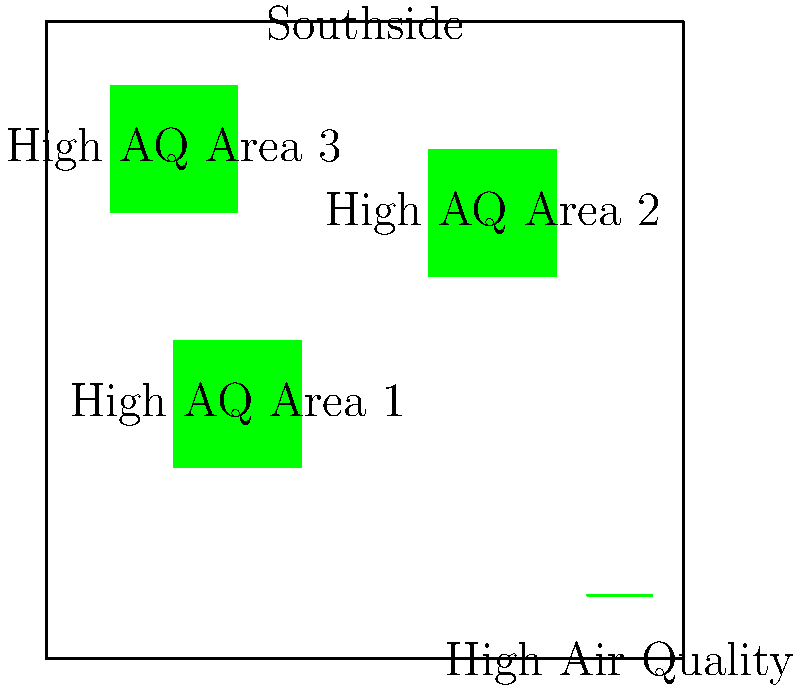According to the map of Chattanooga's Southside, how many distinct areas are highlighted as having the highest air quality readings? To answer this question, we need to carefully examine the provided map of Chattanooga's Southside. The map uses green shading to indicate areas with the highest air quality readings. Let's analyze the map step-by-step:

1. Observe the overall layout of the map, which shows the Southside area of Chattanooga.

2. Look for green-shaded areas, which represent locations with high air quality readings.

3. Count the number of distinct green-shaded areas:
   a. There is a green area in the upper-left quadrant of the map, labeled "High AQ Area 1".
   b. Another green area is visible in the upper-right quadrant, labeled "High AQ Area 2".
   c. A third green area can be seen in the lower-left quadrant, labeled "High AQ Area 3".

4. Confirm that there are no other green-shaded areas on the map.

5. Conclude that there are exactly 3 distinct areas highlighted as having the highest air quality readings in Chattanooga's Southside.

This information is valuable for a concerned parent living in the Southside, as it indicates multiple areas with good air quality, which could be beneficial for children's health and outdoor activities.
Answer: 3 